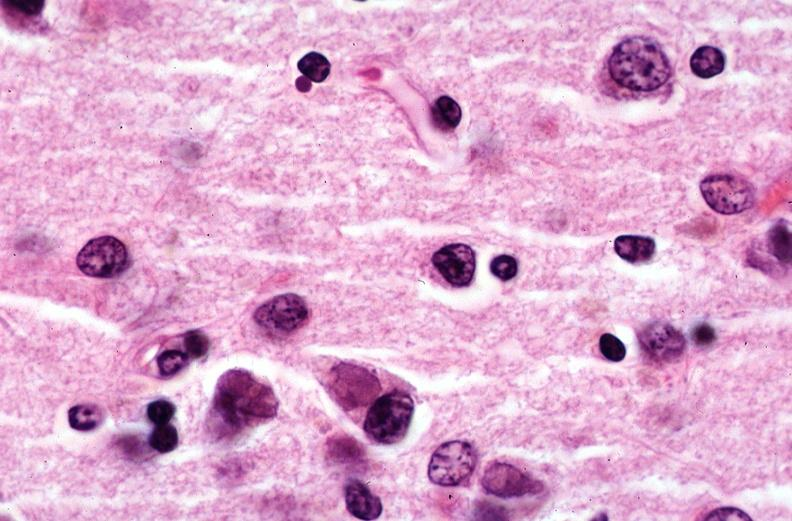does this image show brain, pick 's disease?
Answer the question using a single word or phrase. Yes 